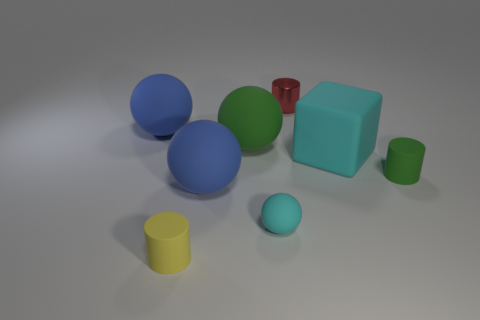Can you describe the lighting in the scene? The scene is lit from above, casting soft shadows beneath the objects, suggesting a diffused light source typical of an overcast day or softbox lighting in a studio. 